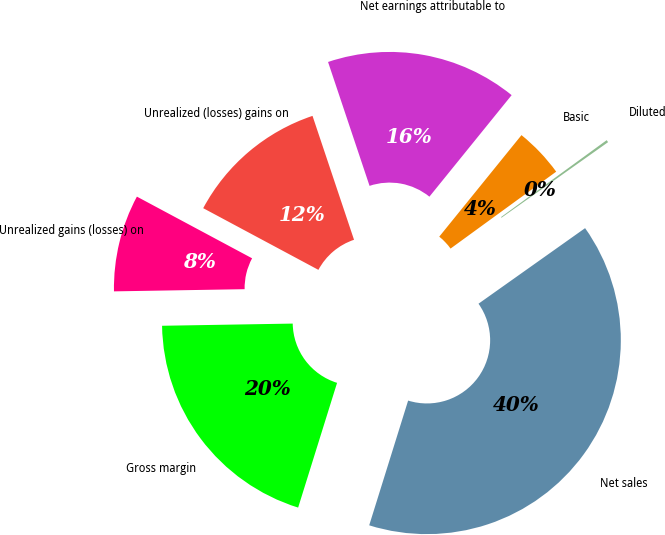Convert chart. <chart><loc_0><loc_0><loc_500><loc_500><pie_chart><fcel>Unrealized (losses) gains on<fcel>Net earnings attributable to<fcel>Basic<fcel>Diluted<fcel>Net sales<fcel>Gross margin<fcel>Unrealized gains (losses) on<nl><fcel>12.03%<fcel>15.98%<fcel>4.15%<fcel>0.2%<fcel>39.63%<fcel>19.92%<fcel>8.09%<nl></chart> 